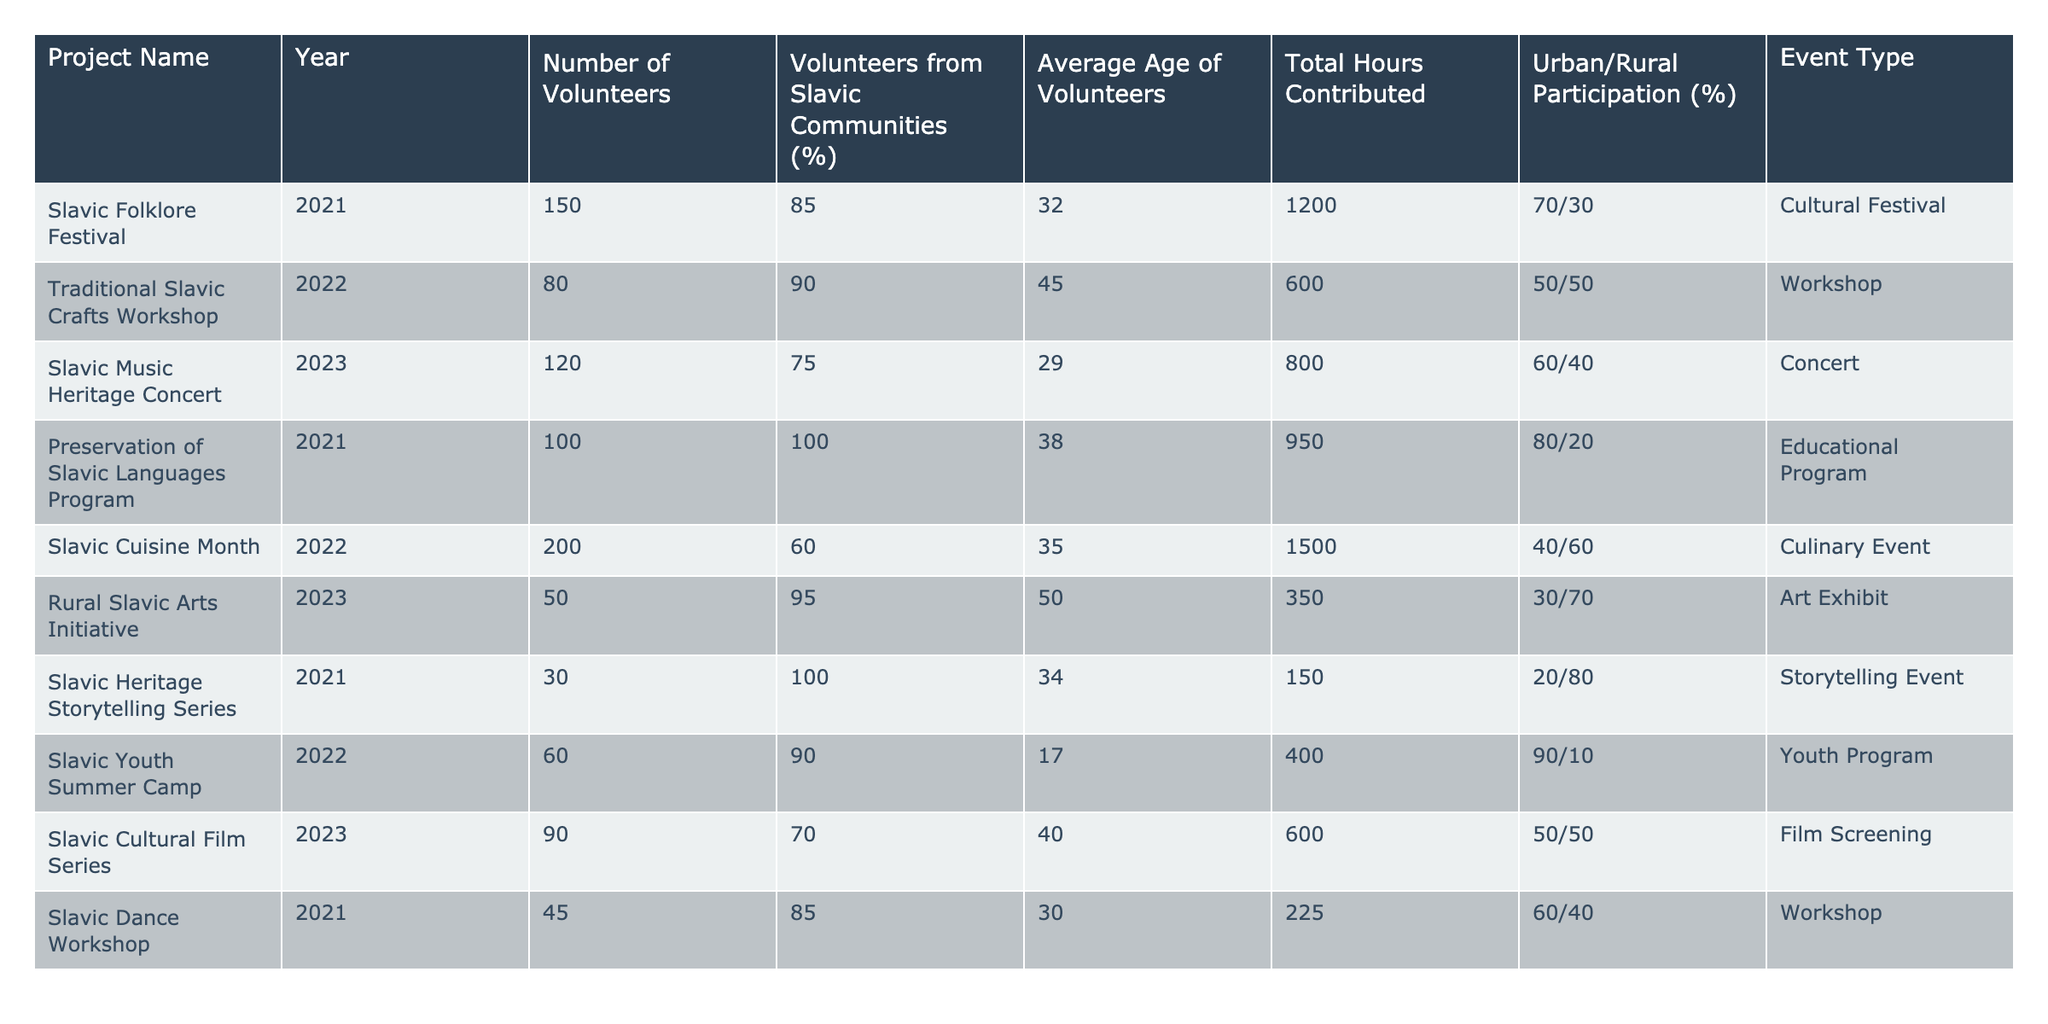What is the average age of volunteers in the "Slavic Folklore Festival"? The table shows that the average age for the "Slavic Folklore Festival" is 32 years. Thus, I can directly refer to the second column under the respective project.
Answer: 32 What percentage of volunteers were from Slavic communities in the "Slavic Heritage Storytelling Series"? In the table, it is stated that 100% of the volunteers in the "Slavic Heritage Storytelling Series" were from Slavic communities.
Answer: 100% Which project had the highest total hours contributed by volunteers? By reviewing the "Total Hours Contributed" column, "Slavic Cuisine Month" has the highest total hours at 1500.
Answer: 1500 How many volunteers participated in "Rural Slavic Arts Initiative"? According to the table, the "Rural Slavic Arts Initiative" had 50 volunteers. This can be found in the "Number of Volunteers" column for that project.
Answer: 50 What is the average age of volunteers for projects held in 2022? The average age is calculated from the projects in 2022: "Traditional Slavic Crafts Workshop" (45), "Slavic Cuisine Month" (35), and "Slavic Youth Summer Camp" (17). Summing them gives 97, and there are 3 projects. Therefore, the average is 97/3 = 32.33, or approximately 32.
Answer: 32 Was there any project in 2023 where the percentage of volunteers from Slavic communities was over 80%? Looking at the "Volunteers from Slavic Communities (%)" column for 2023 projects, "Rural Slavic Arts Initiative" has 95%, which is over 80%. Thus, the answer is yes.
Answer: Yes What is the total number of volunteers across all listed projects? To find the total, I add the number of volunteers from each project: 150 + 80 + 120 + 100 + 200 + 50 + 30 + 60 + 90 + 45 = 1025.
Answer: 1025 How does urban participation compare to rural for the "Slavic Music Heritage Concert"? For this concert, urban participation is 60% and rural is 40%. Hence, there are more volunteers participating from urban areas.
Answer: Urban participation is higher Which event type had the fewest volunteers? The "Slavic Heritage Storytelling Series" had the fewest volunteers, with only 30 participants, which is the least in the "Number of Volunteers" column.
Answer: Storytelling Event What was the total number of hours contributed by volunteers for all workshops? The total number of hours from workshops includes "Traditional Slavic Crafts Workshop" (600) and "Slavic Dance Workshop" (225). Adding these gives 600 + 225 = 825 hours.
Answer: 825 